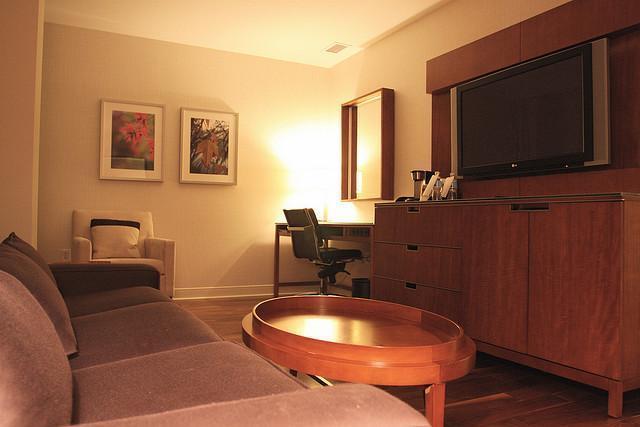How many televisions are in this room?
Give a very brief answer. 1. How many chairs are in the picture?
Give a very brief answer. 2. How many couches are there?
Give a very brief answer. 2. 